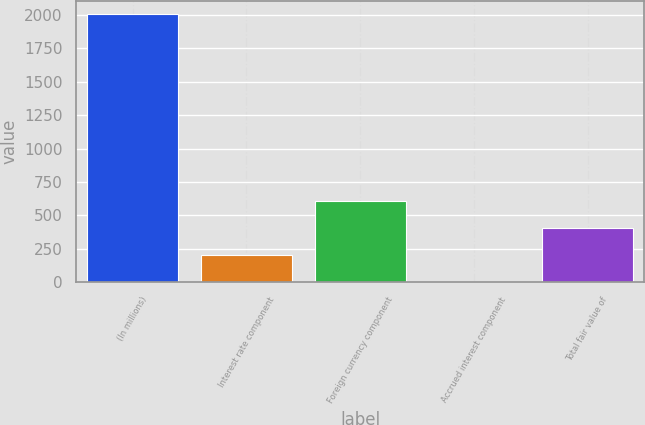Convert chart. <chart><loc_0><loc_0><loc_500><loc_500><bar_chart><fcel>(In millions)<fcel>Interest rate component<fcel>Foreign currency component<fcel>Accrued interest component<fcel>Total fair value of<nl><fcel>2007<fcel>205.2<fcel>605.6<fcel>5<fcel>405.4<nl></chart> 